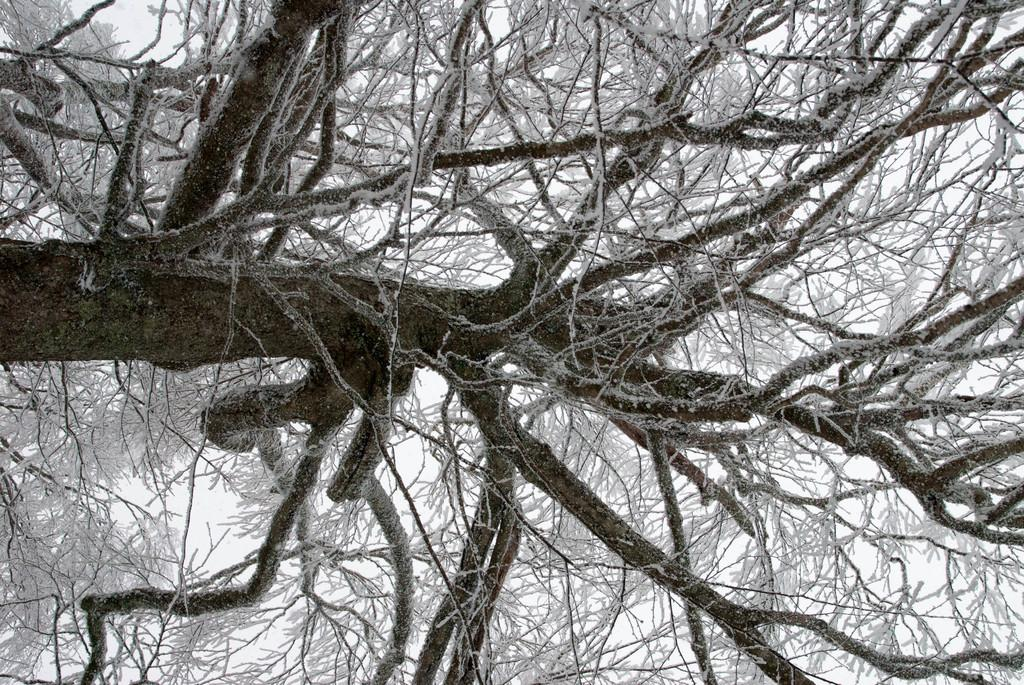What is the color scheme of the image? The image is black and white. What type of natural elements can be seen in the image? There are trees in the image. What is the condition of the trees in the image? The trees are covered with snow. How many ants can be seen crawling on the trees in the image? There are no ants visible in the image, as it is a black and white image of trees covered with snow. 